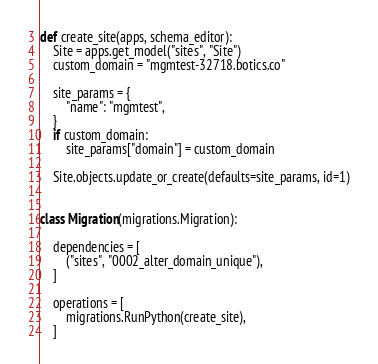Convert code to text. <code><loc_0><loc_0><loc_500><loc_500><_Python_>
def create_site(apps, schema_editor):
    Site = apps.get_model("sites", "Site")
    custom_domain = "mgmtest-32718.botics.co"

    site_params = {
        "name": "mgmtest",
    }
    if custom_domain:
        site_params["domain"] = custom_domain

    Site.objects.update_or_create(defaults=site_params, id=1)


class Migration(migrations.Migration):

    dependencies = [
        ("sites", "0002_alter_domain_unique"),
    ]

    operations = [
        migrations.RunPython(create_site),
    ]
</code> 